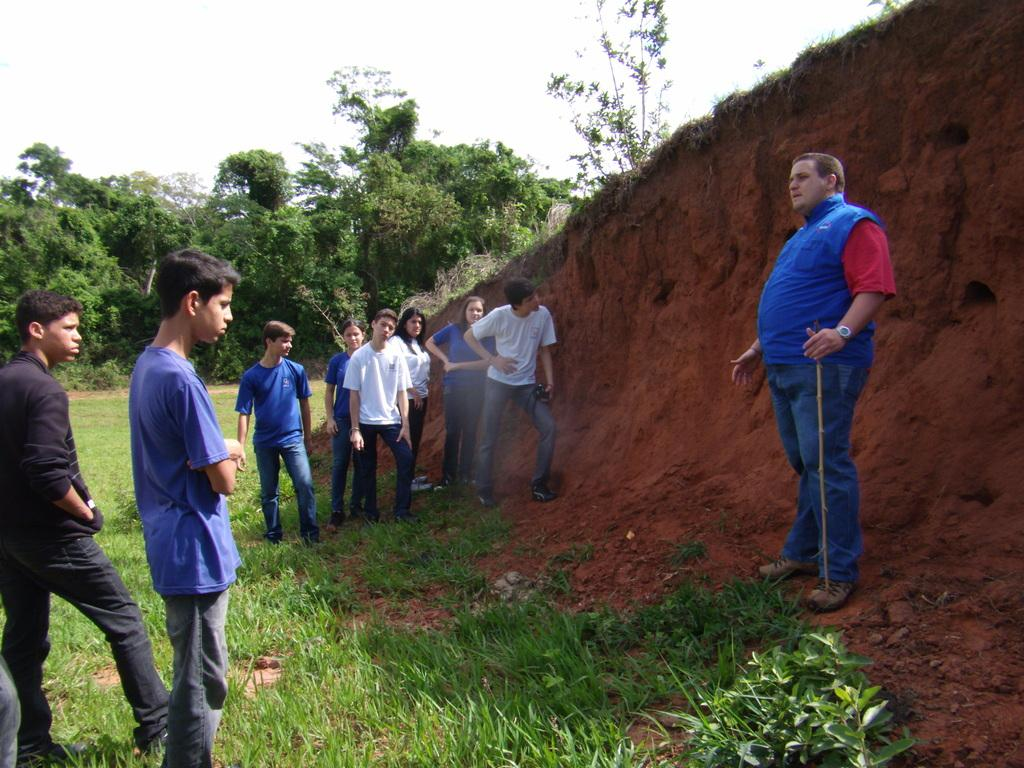What is happening in the image? There are people standing in the image. What are two of the people doing? Two people are holding objects. What type of natural environment is depicted in the image? There are trees, grass, and mud in the image. What can be seen in the background of the image? The sky is visible in the background of the image. What type of toothbrush is visible in the image? There is no toothbrush present in the image. How many pages are visible in the image? There are no pages present in the image. 